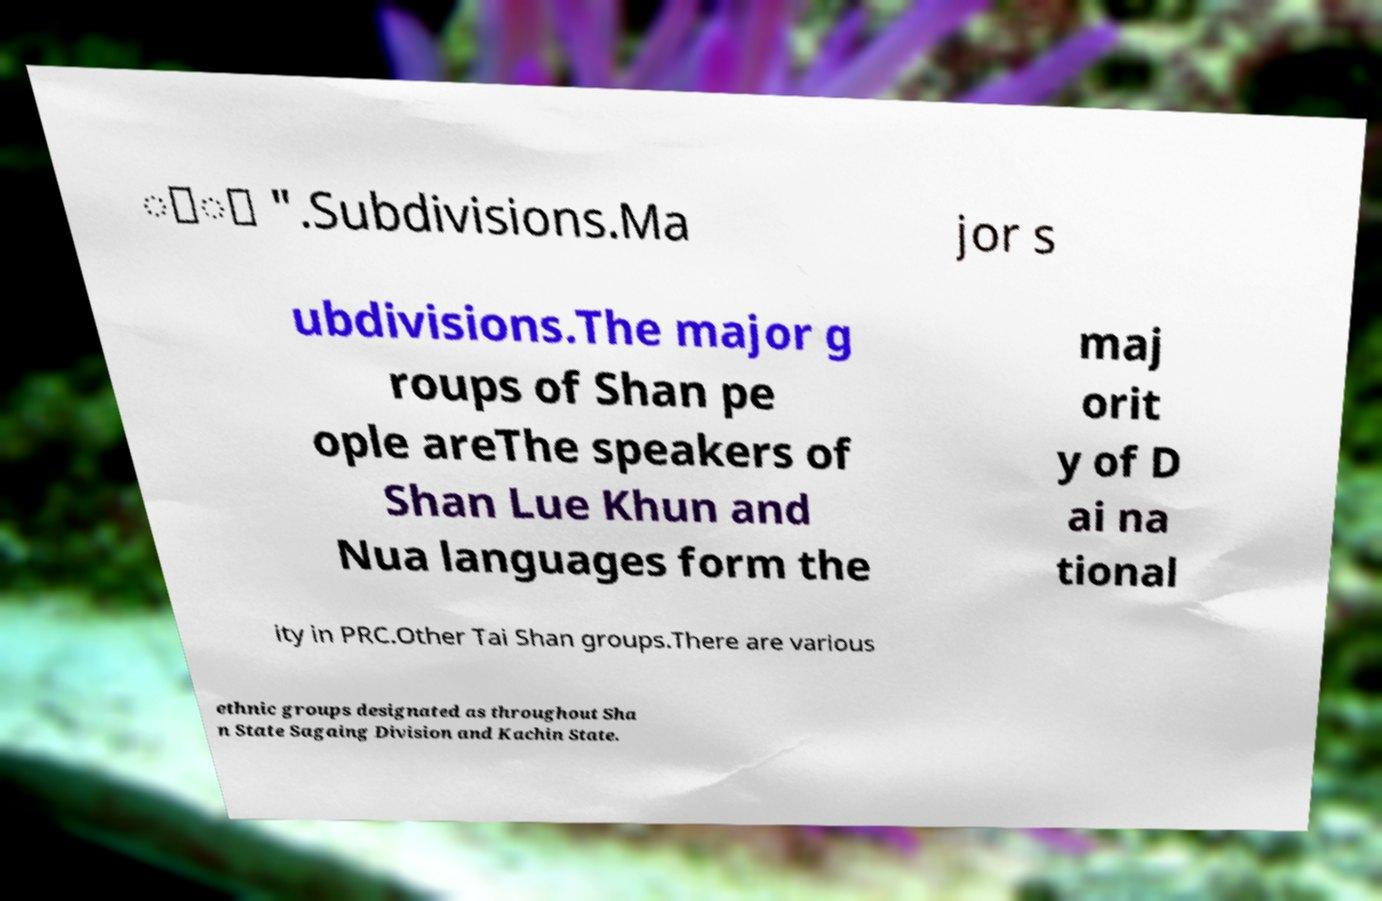Could you extract and type out the text from this image? ေံ ".Subdivisions.Ma jor s ubdivisions.The major g roups of Shan pe ople areThe speakers of Shan Lue Khun and Nua languages form the maj orit y of D ai na tional ity in PRC.Other Tai Shan groups.There are various ethnic groups designated as throughout Sha n State Sagaing Division and Kachin State. 